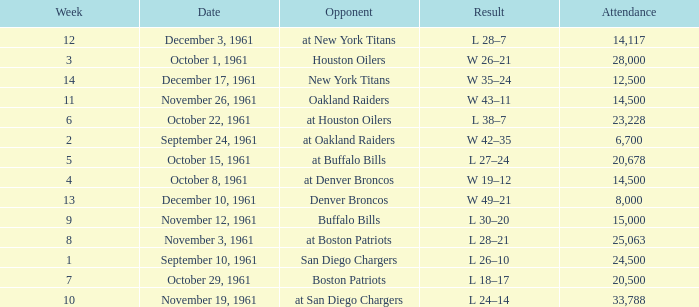What is the low week from october 15, 1961? 5.0. 